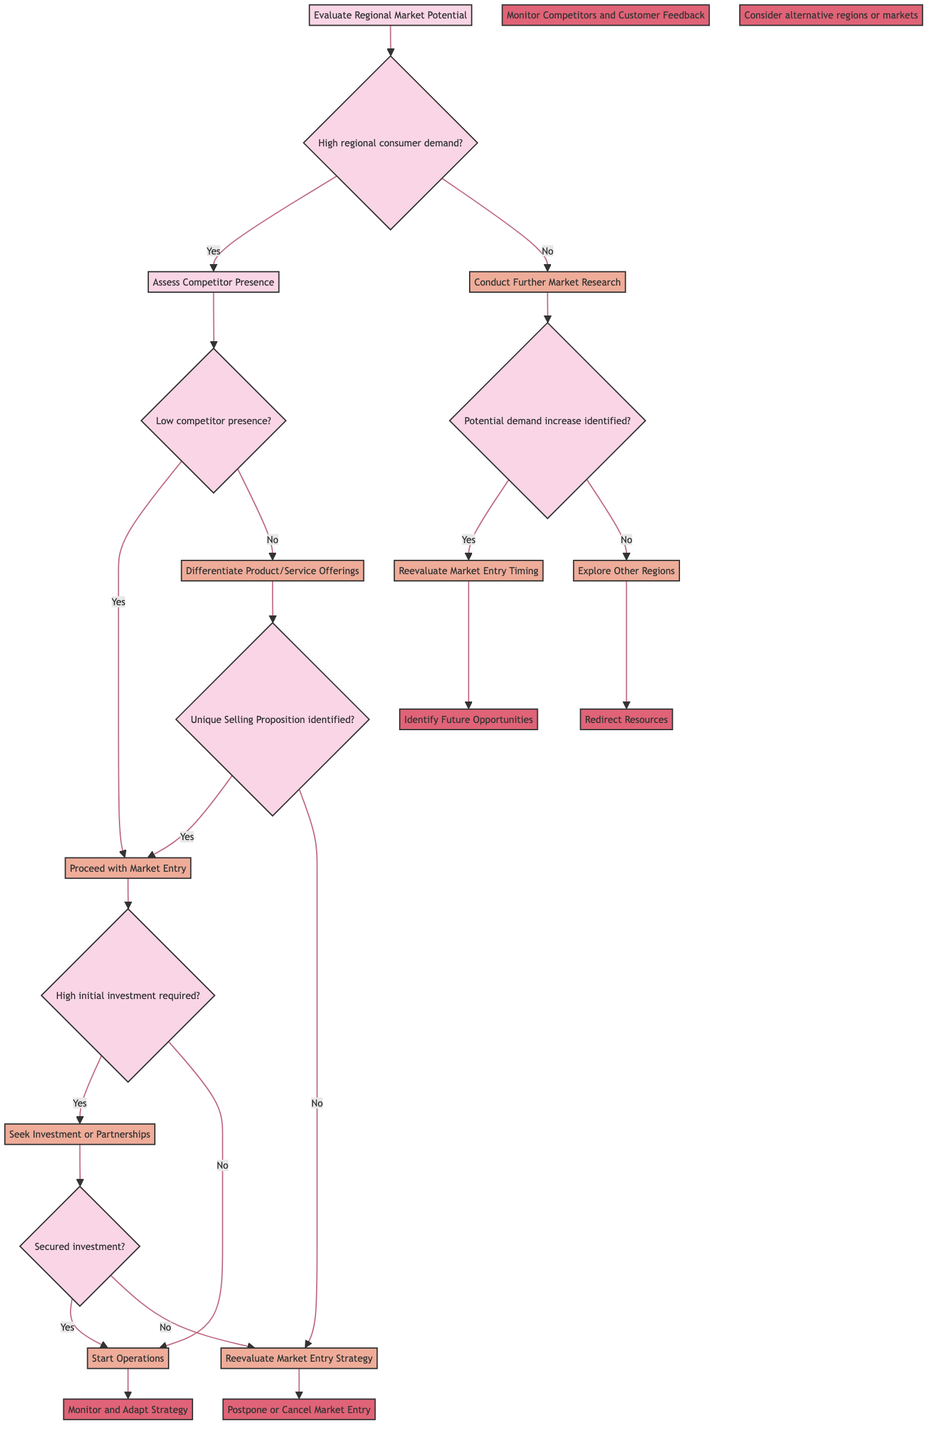What is the first decision node in the diagram? The first decision node is "Evaluate Regional Market Potential," which is the starting point for the decision-making process in the diagram.
Answer: Evaluate Regional Market Potential How many actions are listed under the low competitor presence condition? Under the "Low competitor presence" condition, there are two actions: "Proceed with Market Entry" and "Differentiate Product/Service Offerings." This means there are two actions flowing from this condition.
Answer: Two What should be done if high initial investment is required? If high initial investment is required, the action is to "Seek Investment or Partnerships," which is the next step in the decision tree under that condition.
Answer: Seek Investment or Partnerships What is the outcome if the investment is not secured? If the investment is not secured, the outcome is to "Reevaluate Market Entry Strategy," which leads to either postponing or canceling the market entry.
Answer: Reevaluate Market Entry Strategy Which action is taken if there is low regional consumer demand? If there is low regional consumer demand, the action taken is to "Conduct Further Market Research," which investigates potential demand further.
Answer: Conduct Further Market Research What occurs if a Unique Selling Proposition is identified? If a Unique Selling Proposition (USP) is identified, the action is to "Proceed with Market Entry," meaning the company can initiate their market entry strategy.
Answer: Proceed with Market Entry How many outcomes follow from the "Differentiate Product/Service Offerings" action? Two outcomes follow from the "Differentiate Product/Service Offerings" action: "Monitor Competitors and Customer Feedback" if the USP is identified, and "Reevaluate Market Entry Strategy" if no strong USP is identified. This means there are two distinct outcomes.
Answer: Two What should be considered if no potential demand increase is identified? If no potential demand increase is identified, the action is to "Explore Other Regions," meaning resources should be redirected toward different market opportunities.
Answer: Explore Other Regions What is the outcome after starting operations? After starting operations, the outcome is to "Monitor and Adapt Strategy," which implies an ongoing evaluation of the market response and strategy adjustments as necessary.
Answer: Monitor and Adapt Strategy 